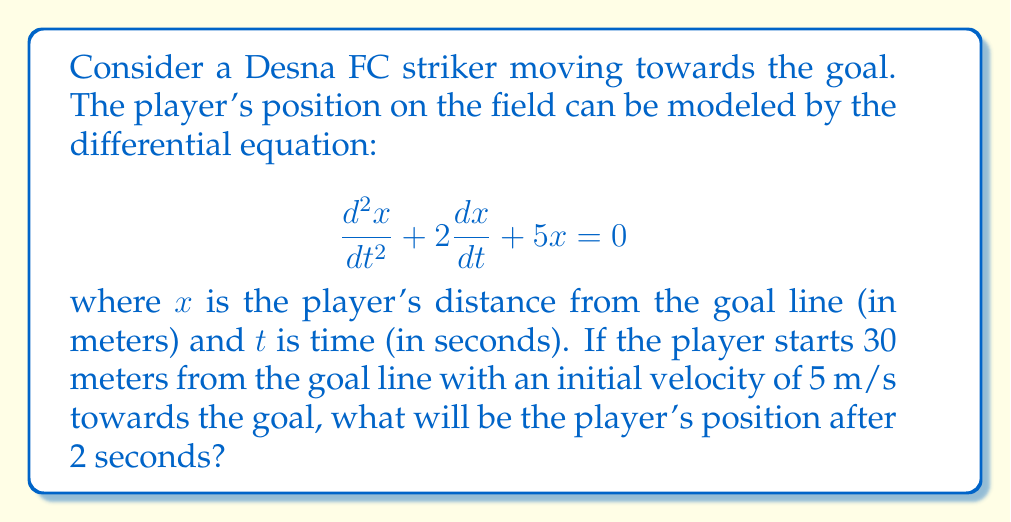Provide a solution to this math problem. To solve this problem, we need to use the theory of second-order linear differential equations. The given equation is in the form:

$$\frac{d^2x}{dt^2} + 2\frac{dx}{dt} + 5x = 0$$

This is a homogeneous second-order linear differential equation with constant coefficients. The general solution for this type of equation is:

$$x(t) = c_1e^{r_1t} + c_2e^{r_2t}$$

where $r_1$ and $r_2$ are the roots of the characteristic equation:

$$r^2 + 2r + 5 = 0$$

Solving this quadratic equation:

$$r = \frac{-2 \pm \sqrt{4 - 20}}{2} = -1 \pm 2i$$

Therefore, the general solution is:

$$x(t) = e^{-t}(c_1\cos(2t) + c_2\sin(2t))$$

Now, we need to use the initial conditions to find $c_1$ and $c_2$:

1) $x(0) = 30$ (initial position)
2) $\frac{dx}{dt}(0) = -5$ (initial velocity, negative because it's towards the goal)

From the first condition:
$$30 = c_1$$

From the second condition:
$$-5 = -c_1 + 2c_2$$

Solving these equations:
$$c_1 = 30, c_2 = 12.5$$

Thus, the particular solution is:

$$x(t) = e^{-t}(30\cos(2t) + 12.5\sin(2t))$$

To find the position after 2 seconds, we substitute $t=2$:

$$x(2) = e^{-2}(30\cos(4) + 12.5\sin(4))$$
Answer: $x(2) \approx 4.06$ meters

The striker will be approximately 4.06 meters from the goal line after 2 seconds. 